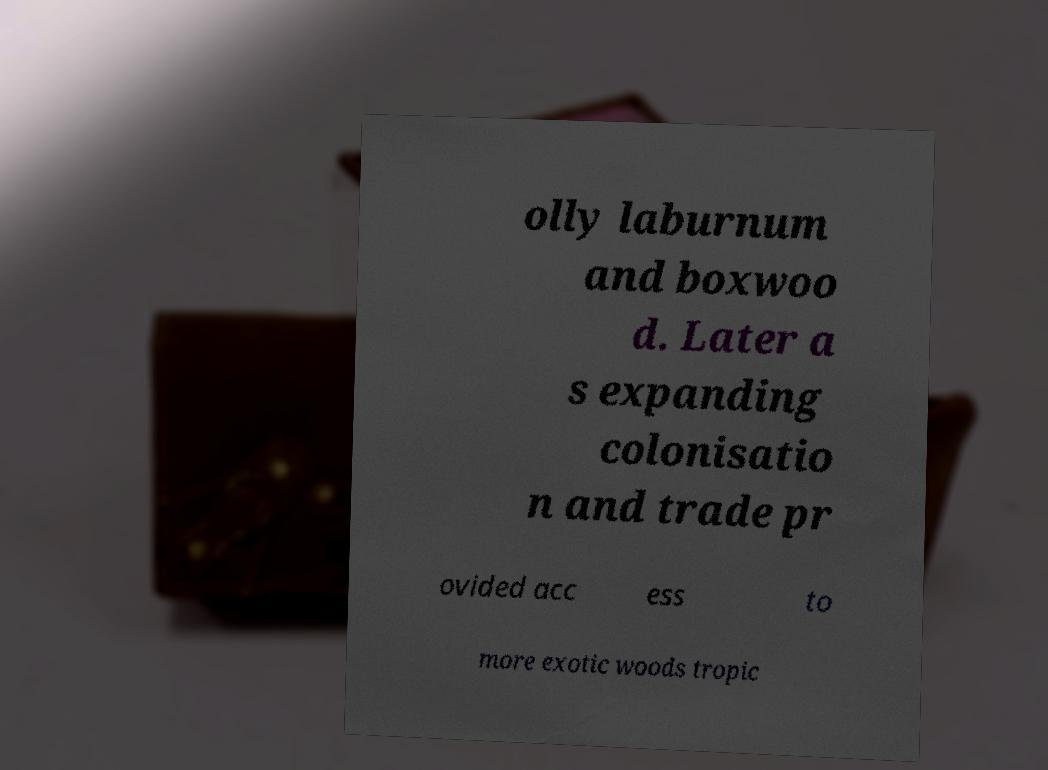I need the written content from this picture converted into text. Can you do that? olly laburnum and boxwoo d. Later a s expanding colonisatio n and trade pr ovided acc ess to more exotic woods tropic 